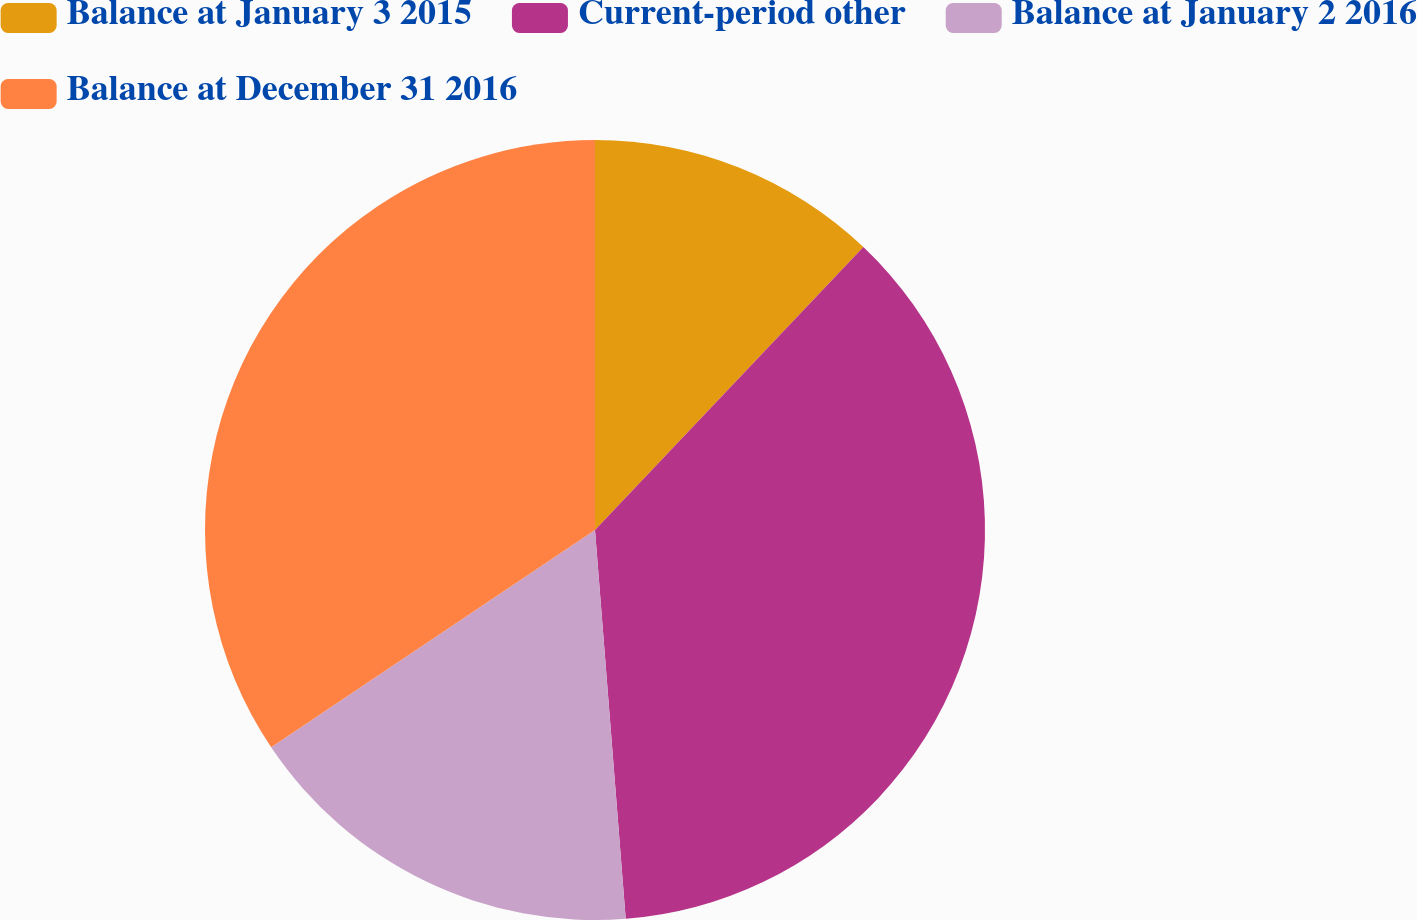Convert chart. <chart><loc_0><loc_0><loc_500><loc_500><pie_chart><fcel>Balance at January 3 2015<fcel>Current-period other<fcel>Balance at January 2 2016<fcel>Balance at December 31 2016<nl><fcel>12.08%<fcel>36.67%<fcel>16.85%<fcel>34.41%<nl></chart> 